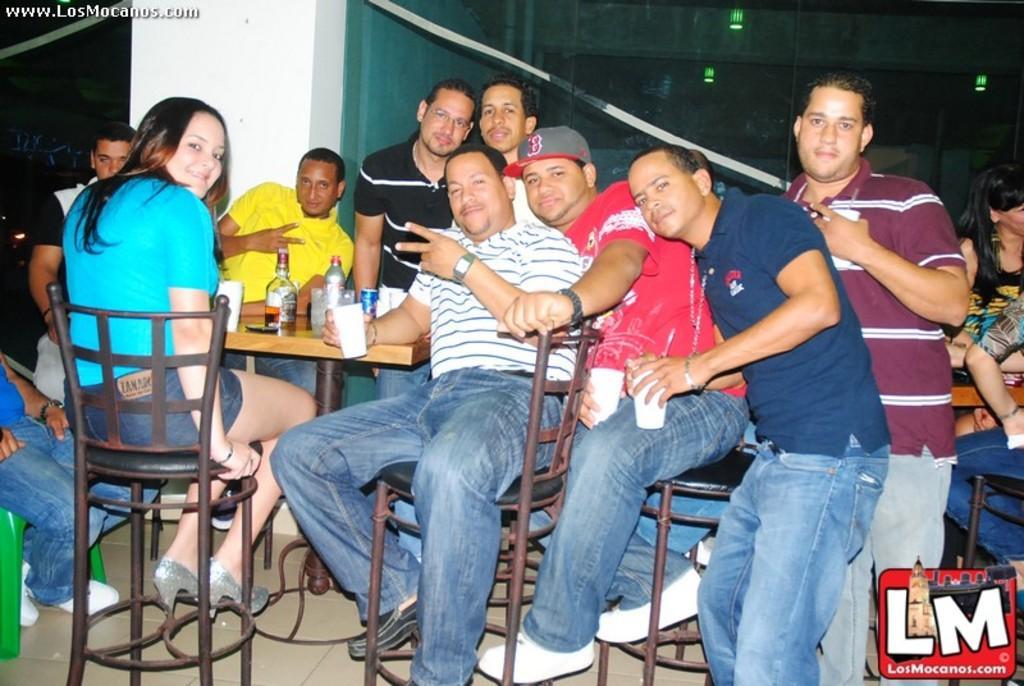How would you summarize this image in a sentence or two? In the center of the image we can see people sitting and there is a table. We can see bottles placed on the table. On the right there is a man standing. In the background there are people, lights and a wall. 